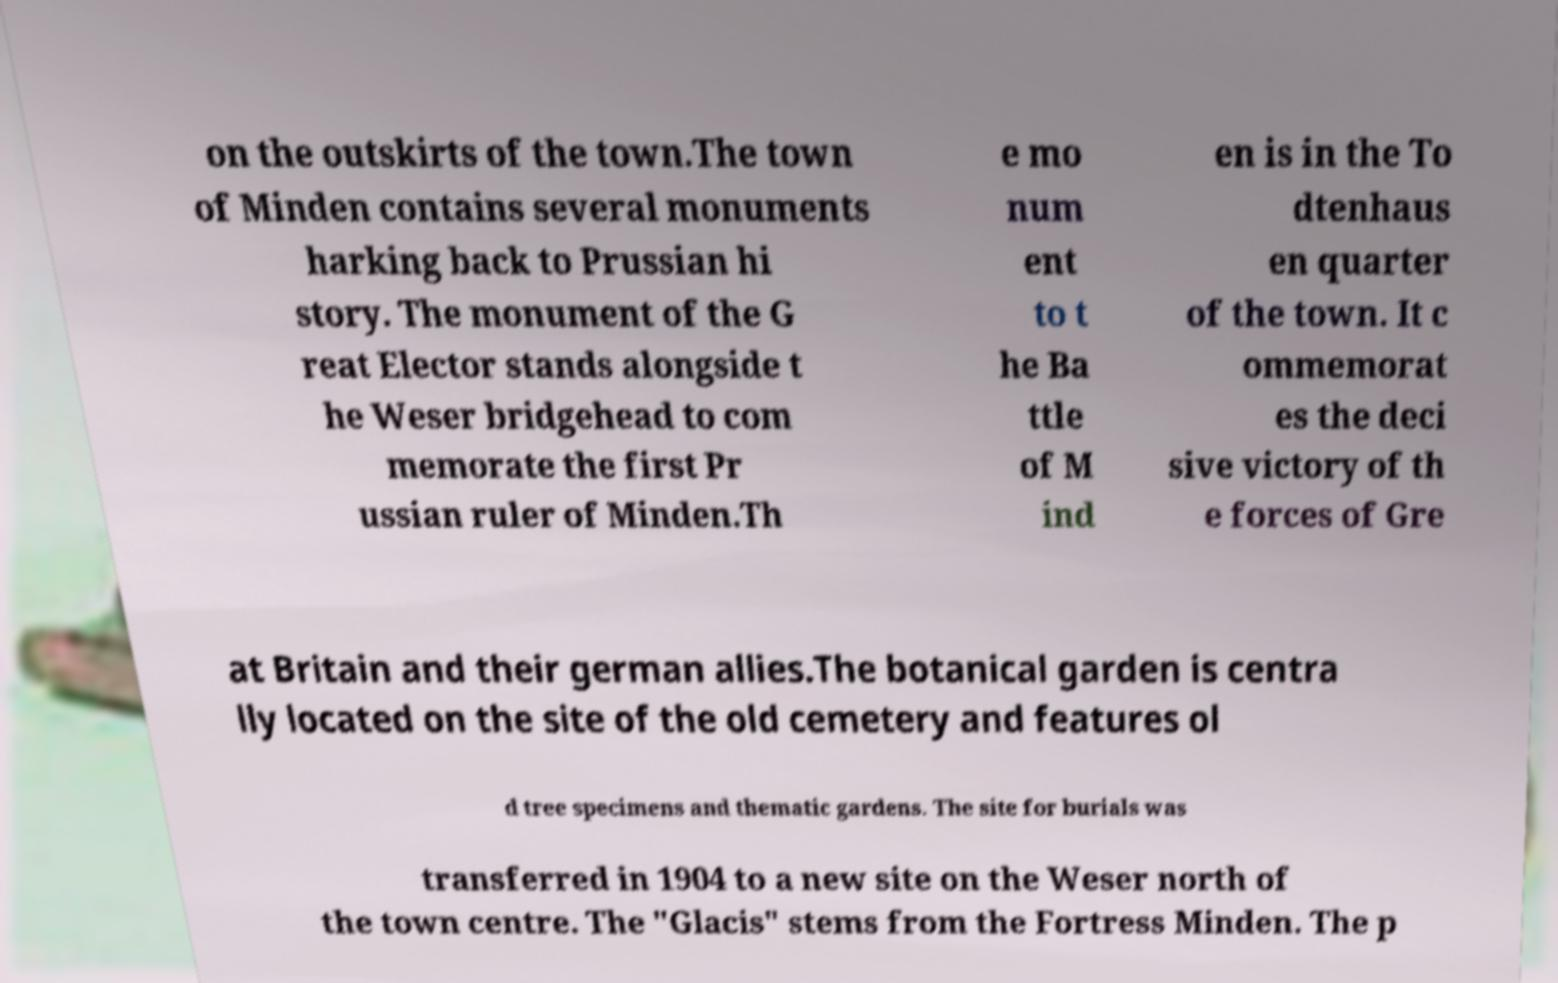Can you read and provide the text displayed in the image?This photo seems to have some interesting text. Can you extract and type it out for me? on the outskirts of the town.The town of Minden contains several monuments harking back to Prussian hi story. The monument of the G reat Elector stands alongside t he Weser bridgehead to com memorate the first Pr ussian ruler of Minden.Th e mo num ent to t he Ba ttle of M ind en is in the To dtenhaus en quarter of the town. It c ommemorat es the deci sive victory of th e forces of Gre at Britain and their german allies.The botanical garden is centra lly located on the site of the old cemetery and features ol d tree specimens and thematic gardens. The site for burials was transferred in 1904 to a new site on the Weser north of the town centre. The "Glacis" stems from the Fortress Minden. The p 